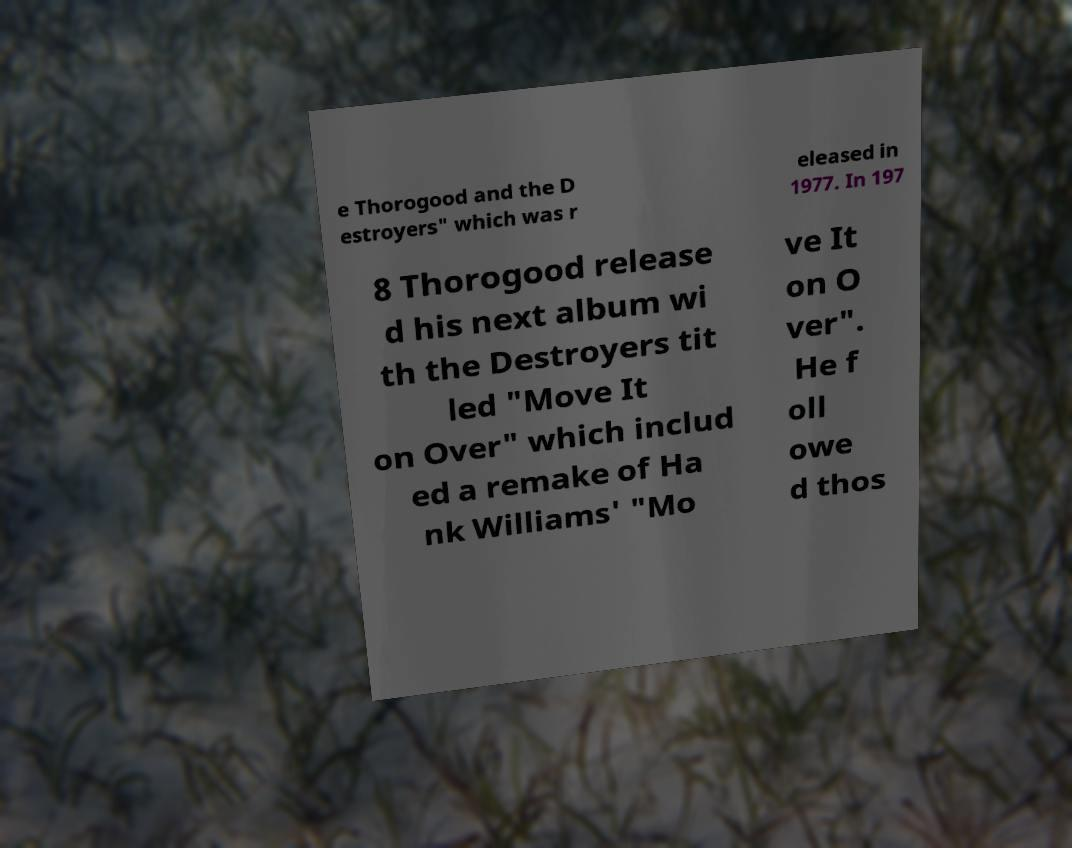There's text embedded in this image that I need extracted. Can you transcribe it verbatim? e Thorogood and the D estroyers" which was r eleased in 1977. In 197 8 Thorogood release d his next album wi th the Destroyers tit led "Move It on Over" which includ ed a remake of Ha nk Williams' "Mo ve It on O ver". He f oll owe d thos 